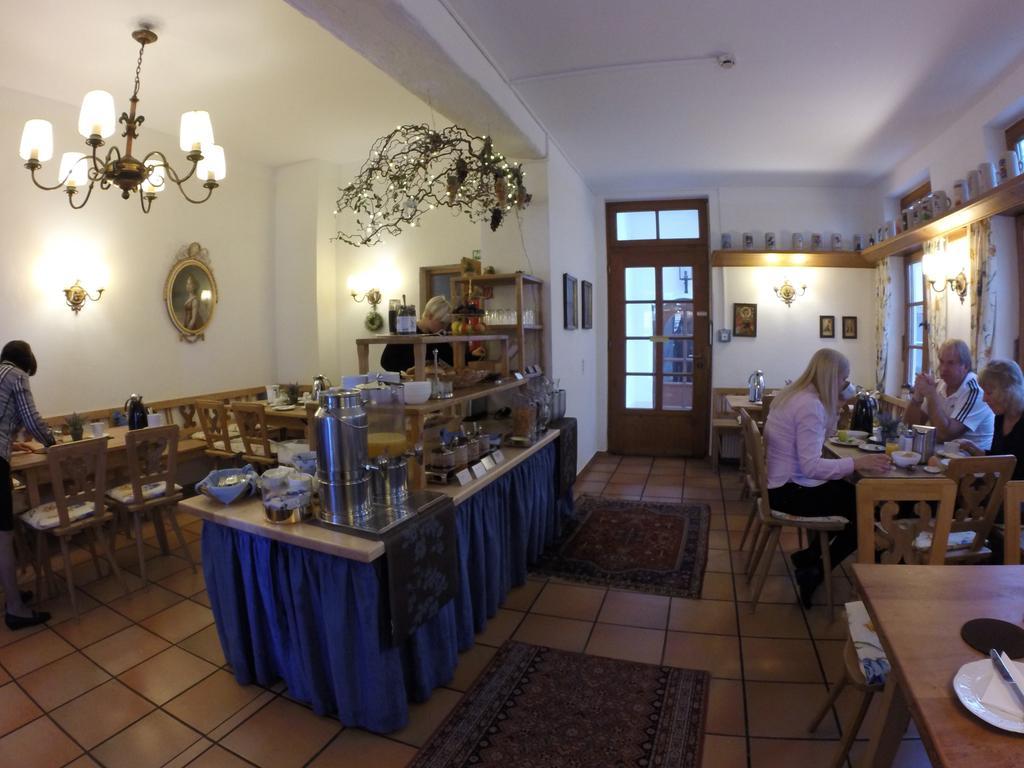In one or two sentences, can you explain what this image depicts? A picture inside of a room. On top there are lights. We can able to see chairs and tables. On this table there are plates and bowl. On this table there are things. The persons are sitting on a chair. Floor with carpet. This is door. A pictures on wall. 